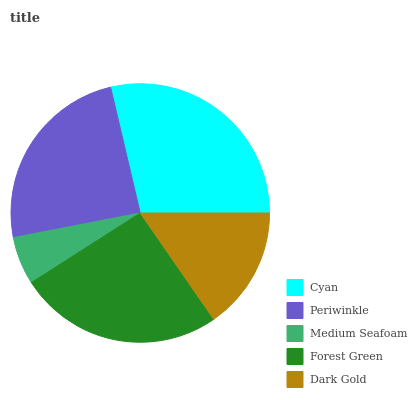Is Medium Seafoam the minimum?
Answer yes or no. Yes. Is Cyan the maximum?
Answer yes or no. Yes. Is Periwinkle the minimum?
Answer yes or no. No. Is Periwinkle the maximum?
Answer yes or no. No. Is Cyan greater than Periwinkle?
Answer yes or no. Yes. Is Periwinkle less than Cyan?
Answer yes or no. Yes. Is Periwinkle greater than Cyan?
Answer yes or no. No. Is Cyan less than Periwinkle?
Answer yes or no. No. Is Periwinkle the high median?
Answer yes or no. Yes. Is Periwinkle the low median?
Answer yes or no. Yes. Is Cyan the high median?
Answer yes or no. No. Is Cyan the low median?
Answer yes or no. No. 